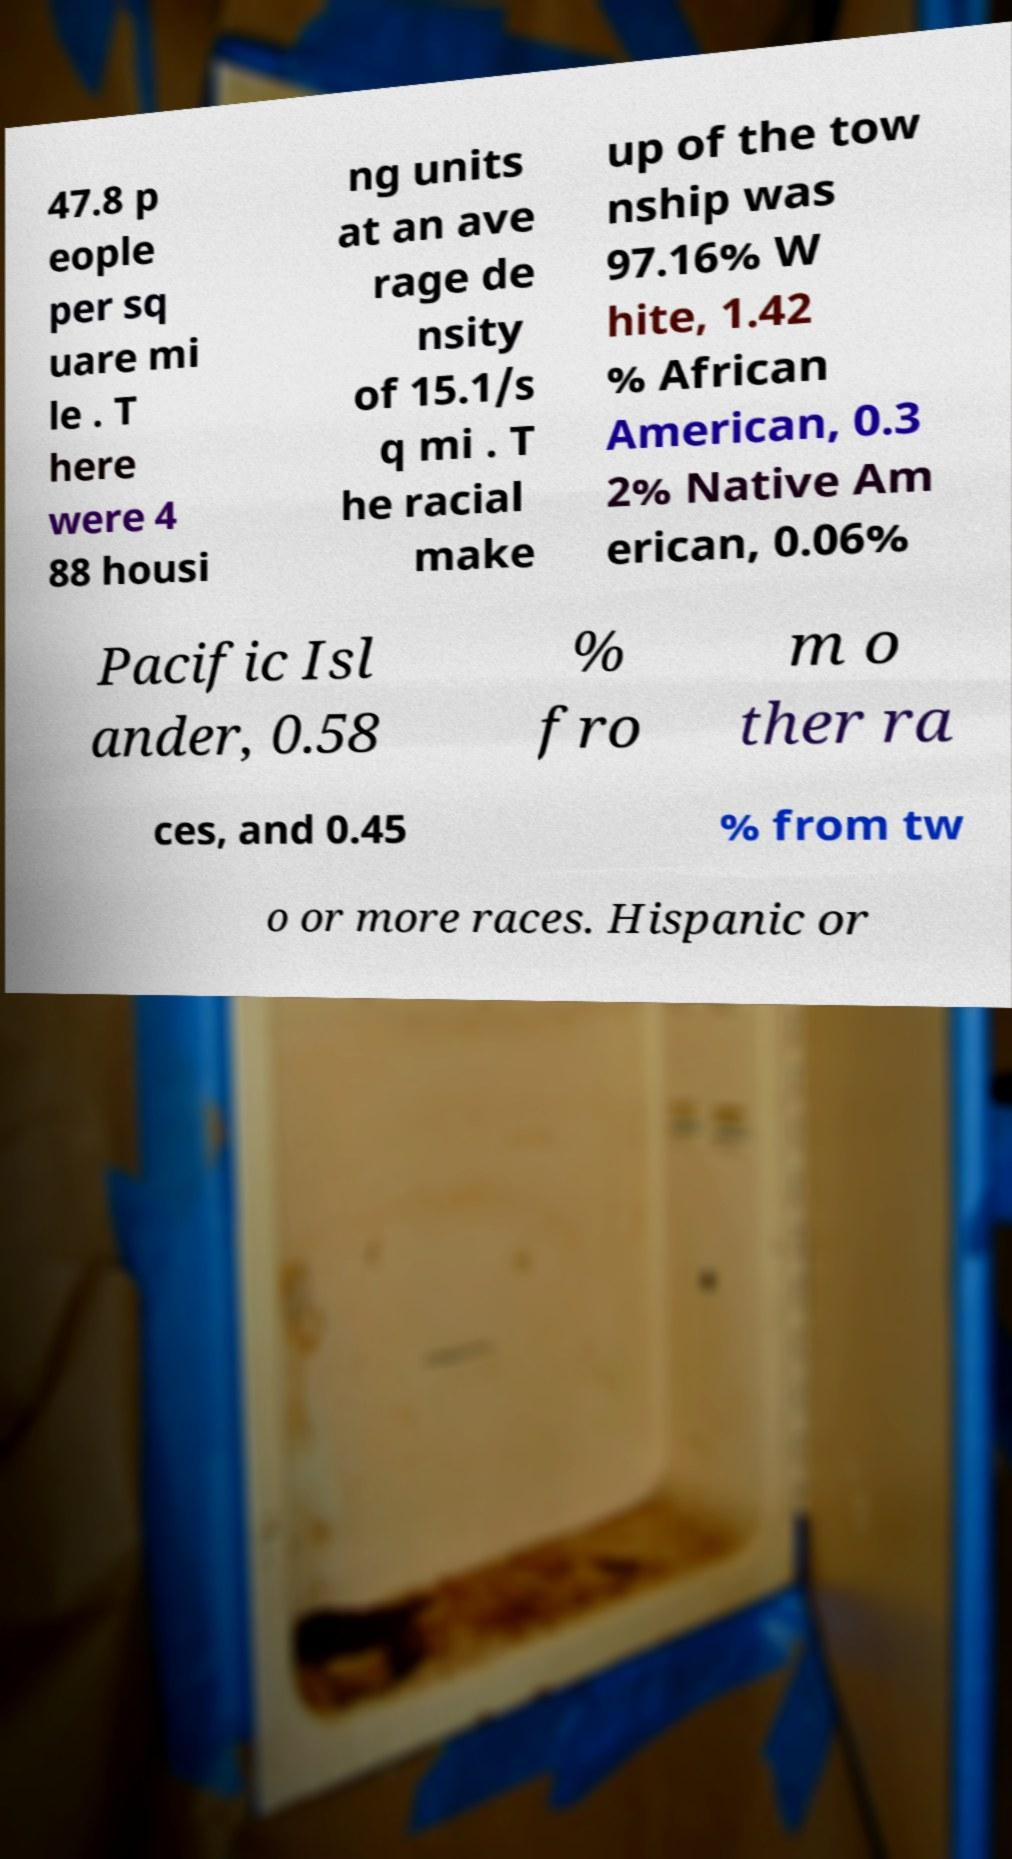Can you read and provide the text displayed in the image?This photo seems to have some interesting text. Can you extract and type it out for me? 47.8 p eople per sq uare mi le . T here were 4 88 housi ng units at an ave rage de nsity of 15.1/s q mi . T he racial make up of the tow nship was 97.16% W hite, 1.42 % African American, 0.3 2% Native Am erican, 0.06% Pacific Isl ander, 0.58 % fro m o ther ra ces, and 0.45 % from tw o or more races. Hispanic or 